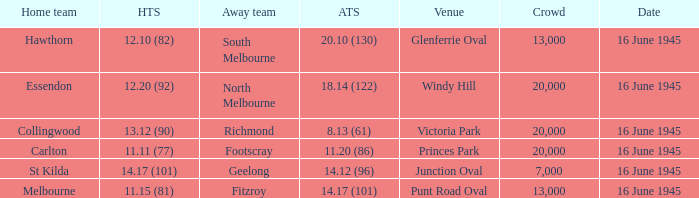What was the Away team score for Footscray? 11.20 (86). Write the full table. {'header': ['Home team', 'HTS', 'Away team', 'ATS', 'Venue', 'Crowd', 'Date'], 'rows': [['Hawthorn', '12.10 (82)', 'South Melbourne', '20.10 (130)', 'Glenferrie Oval', '13,000', '16 June 1945'], ['Essendon', '12.20 (92)', 'North Melbourne', '18.14 (122)', 'Windy Hill', '20,000', '16 June 1945'], ['Collingwood', '13.12 (90)', 'Richmond', '8.13 (61)', 'Victoria Park', '20,000', '16 June 1945'], ['Carlton', '11.11 (77)', 'Footscray', '11.20 (86)', 'Princes Park', '20,000', '16 June 1945'], ['St Kilda', '14.17 (101)', 'Geelong', '14.12 (96)', 'Junction Oval', '7,000', '16 June 1945'], ['Melbourne', '11.15 (81)', 'Fitzroy', '14.17 (101)', 'Punt Road Oval', '13,000', '16 June 1945']]} 